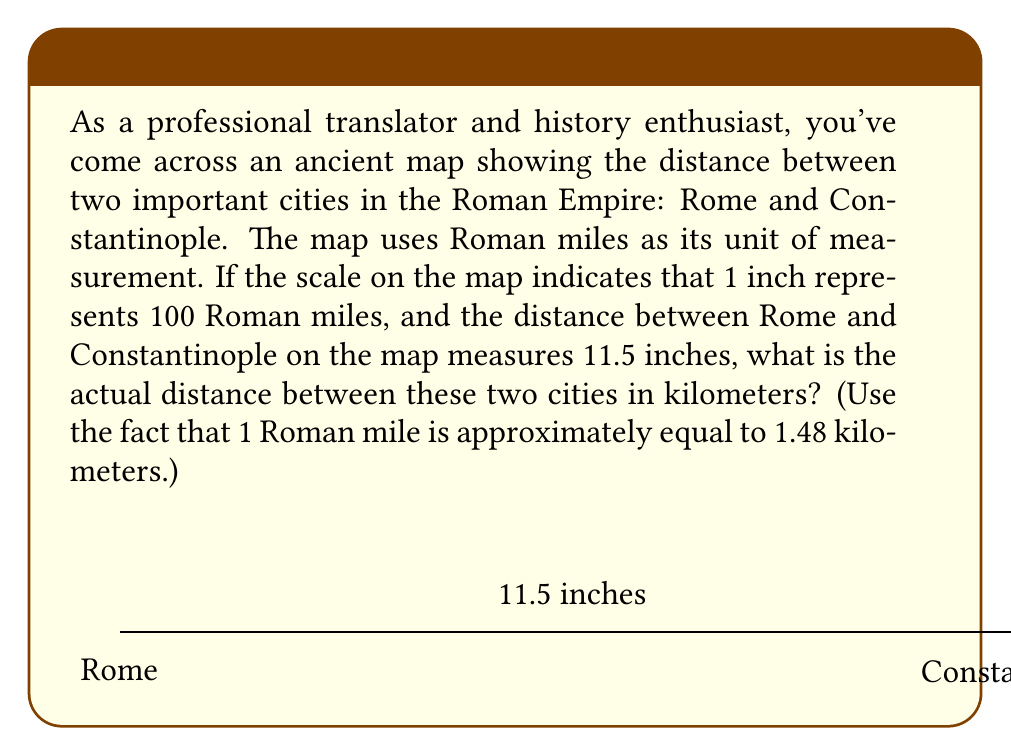Can you solve this math problem? Let's approach this problem step by step:

1) First, we need to convert the map distance to Roman miles:
   $11.5 \text{ inches} \times 100 \text{ Roman miles/inch} = 1150 \text{ Roman miles}$

2) Now, we need to convert Roman miles to kilometers. We're given that 1 Roman mile ≈ 1.48 kilometers.
   Let's set up the conversion:

   $$1150 \text{ Roman miles} \times 1.48 \text{ km/Roman mile} = 1702 \text{ km}$$

3) Let's do the calculation:
   $$1150 \times 1.48 = 1702$$

Therefore, the actual distance between Rome and Constantinople is approximately 1702 kilometers.
Answer: 1702 km 